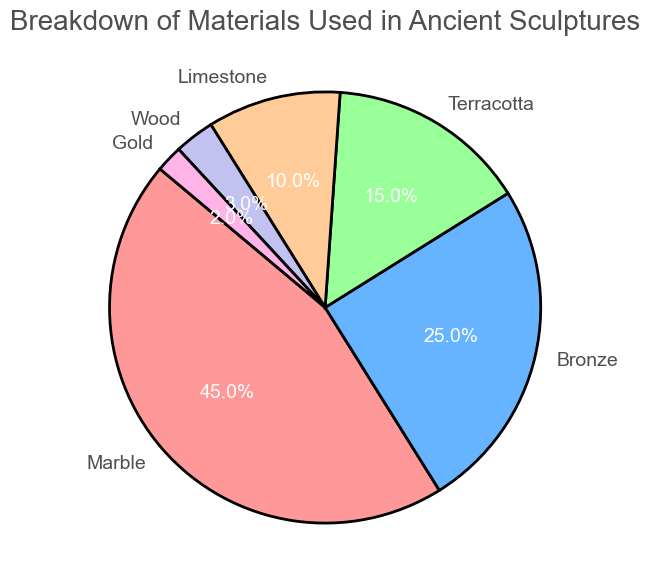Which material makes up the largest portion of ancient sculptures? The figure shows a breakdown where the material with the highest percentage in the pie chart is the largest portion. Marble occupies 45%, which is the largest.
Answer: Marble Which two materials together make up more than half of the ancient sculptures? To determine if two materials together make up more than half, sum their percentages and check if it exceeds 50%. Marble (45%) and Bronze (25%) together account for 70%.
Answer: Marble and Bronze Which material has a smaller percentage than both Limestone and Terracotta? Identify the materials represented by smaller percentages than Limestone (10%) and Terracotta (15%). Wood (3%) and Gold (2%) are smaller than both.
Answer: Wood and Gold How much more percentage does Marble occupy compared to Terracotta? Subtract the percentage of Terracotta (15%) from Marble (45%) to find the difference. 45% - 15% = 30%.
Answer: 30% Which material's percentage is half of the percentage of Bronze? Check which material's percentage equals half of Bronze's percentage. Bronze is 25%, half of which is 12.5%. Limestone is closest at 10%.
Answer: Limestone What is the combined percentage of the two least frequently used materials? Add the percentages of the two smallest segments. Wood (3%) and Gold (2%) together make 3% + 2% = 5%.
Answer: 5% Between Limestone and Wood, which material is used less, and by how much? Compare the percentages of Limestone (10%) and Wood (3%) and subtract to find the difference. 10% - 3% = 7%.
Answer: Wood by 7% Are there any materials that occupy exactly 20% of the sculptures? Examine the chart for any material segments labeled with 20%. There are none.
Answer: No What is the difference in percentage between the most and least used materials? Subtract the percentage of the least used material (Gold: 2%) from the most used material (Marble: 45%). 45% - 2% = 43%.
Answer: 43% Which three materials together account for 85% of the sculptures? Sum the percentages to find three materials that collectively total 85%. Marble (45%), Bronze (25%), and Terracotta (15%) sum to 45% + 25% + 15% = 85%.
Answer: Marble, Bronze, and Terracotta 